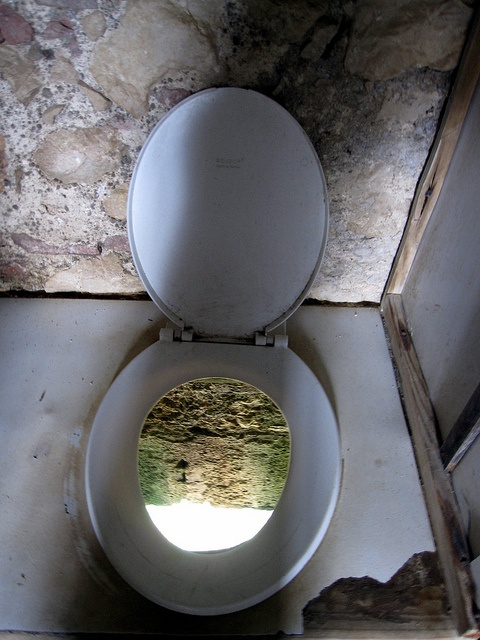Describe the objects in this image and their specific colors. I can see a toilet in gray, black, white, and darkgreen tones in this image. 